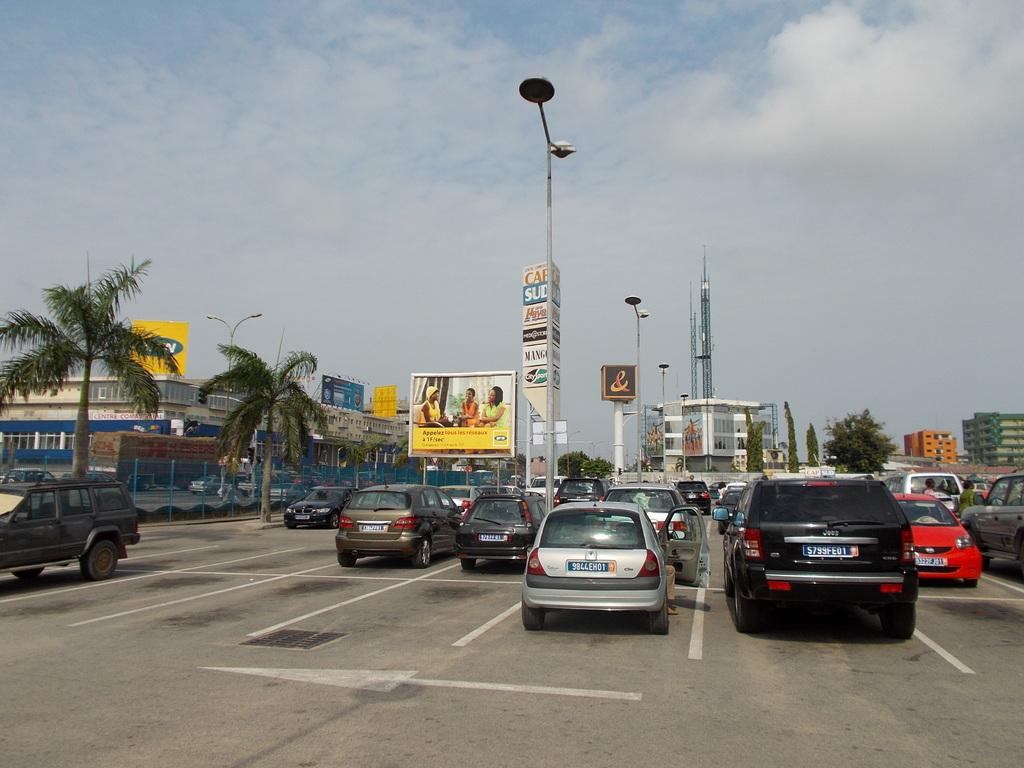What type of vehicles can be seen in the image? There are cars in the image. What type of natural elements are present in the image? There are trees in the image. What type of structures can be seen in the image? There are poles with lights and wires in the image. What type of board is being used by the prisoners in the image? There are no prisoners or boards present in the image. 